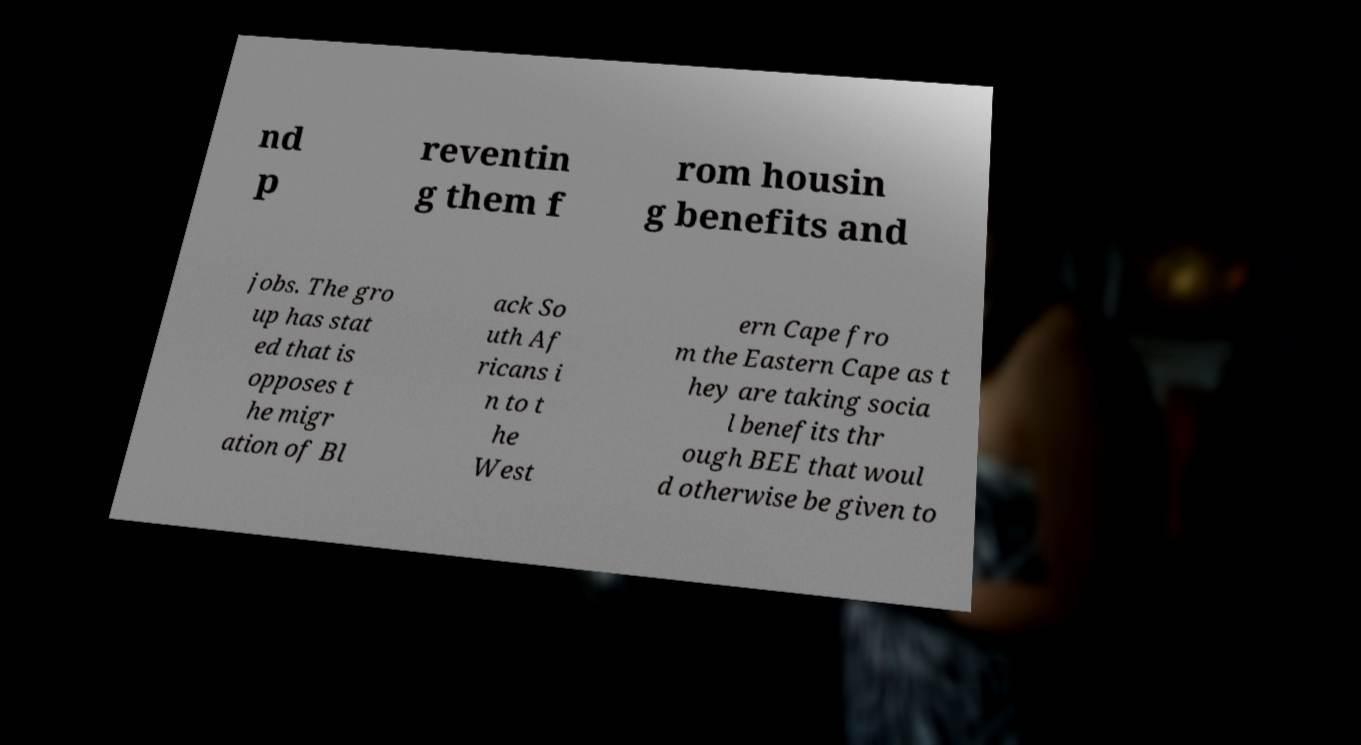Please read and relay the text visible in this image. What does it say? nd p reventin g them f rom housin g benefits and jobs. The gro up has stat ed that is opposes t he migr ation of Bl ack So uth Af ricans i n to t he West ern Cape fro m the Eastern Cape as t hey are taking socia l benefits thr ough BEE that woul d otherwise be given to 